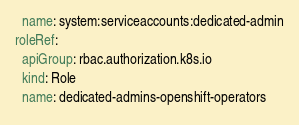<code> <loc_0><loc_0><loc_500><loc_500><_YAML_>  name: system:serviceaccounts:dedicated-admin
roleRef:
  apiGroup: rbac.authorization.k8s.io
  kind: Role
  name: dedicated-admins-openshift-operators
</code> 